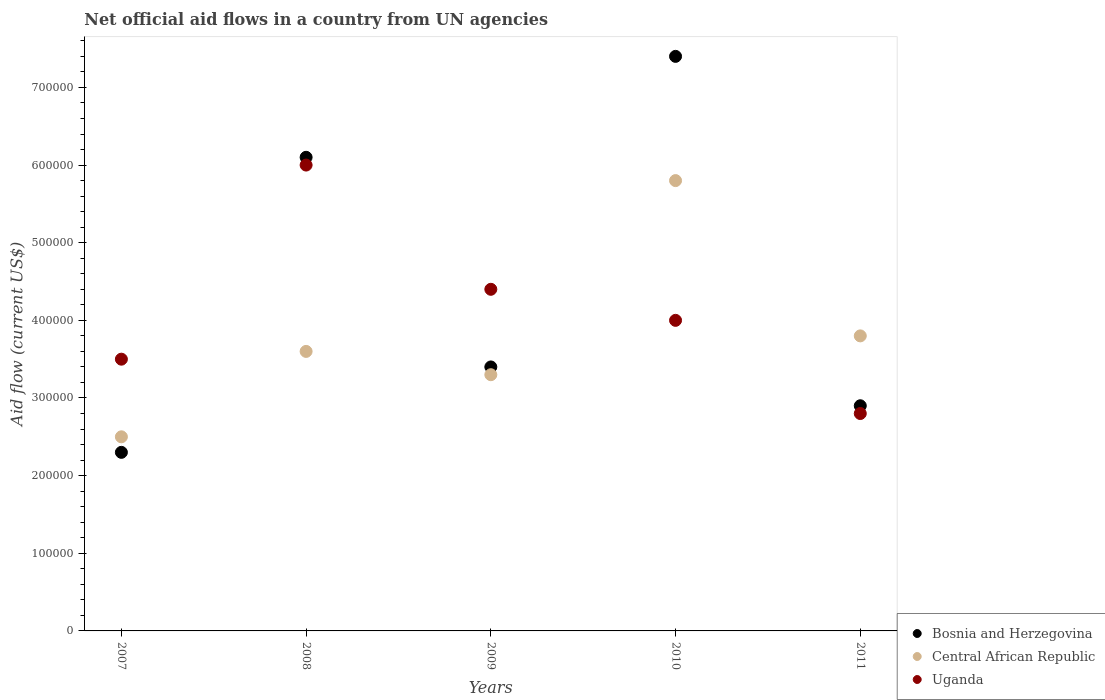How many different coloured dotlines are there?
Provide a succinct answer. 3. Is the number of dotlines equal to the number of legend labels?
Keep it short and to the point. Yes. What is the net official aid flow in Central African Republic in 2010?
Offer a very short reply. 5.80e+05. Across all years, what is the maximum net official aid flow in Bosnia and Herzegovina?
Give a very brief answer. 7.40e+05. Across all years, what is the minimum net official aid flow in Central African Republic?
Offer a very short reply. 2.50e+05. In which year was the net official aid flow in Bosnia and Herzegovina maximum?
Your answer should be compact. 2010. In which year was the net official aid flow in Uganda minimum?
Provide a short and direct response. 2011. What is the total net official aid flow in Central African Republic in the graph?
Make the answer very short. 1.90e+06. What is the difference between the net official aid flow in Bosnia and Herzegovina in 2009 and that in 2011?
Ensure brevity in your answer.  5.00e+04. What is the difference between the net official aid flow in Bosnia and Herzegovina in 2011 and the net official aid flow in Uganda in 2008?
Your response must be concise. -3.10e+05. In the year 2011, what is the difference between the net official aid flow in Uganda and net official aid flow in Bosnia and Herzegovina?
Ensure brevity in your answer.  -10000. What is the ratio of the net official aid flow in Uganda in 2007 to that in 2009?
Ensure brevity in your answer.  0.8. What is the difference between the highest and the lowest net official aid flow in Uganda?
Give a very brief answer. 3.20e+05. In how many years, is the net official aid flow in Central African Republic greater than the average net official aid flow in Central African Republic taken over all years?
Provide a succinct answer. 1. Is the sum of the net official aid flow in Uganda in 2007 and 2009 greater than the maximum net official aid flow in Bosnia and Herzegovina across all years?
Provide a short and direct response. Yes. What is the difference between two consecutive major ticks on the Y-axis?
Ensure brevity in your answer.  1.00e+05. Does the graph contain grids?
Offer a very short reply. No. Where does the legend appear in the graph?
Your response must be concise. Bottom right. How are the legend labels stacked?
Provide a succinct answer. Vertical. What is the title of the graph?
Offer a terse response. Net official aid flows in a country from UN agencies. Does "San Marino" appear as one of the legend labels in the graph?
Give a very brief answer. No. What is the label or title of the X-axis?
Offer a terse response. Years. What is the Aid flow (current US$) of Central African Republic in 2007?
Your answer should be compact. 2.50e+05. What is the Aid flow (current US$) in Uganda in 2007?
Offer a terse response. 3.50e+05. What is the Aid flow (current US$) of Uganda in 2008?
Keep it short and to the point. 6.00e+05. What is the Aid flow (current US$) of Bosnia and Herzegovina in 2009?
Offer a terse response. 3.40e+05. What is the Aid flow (current US$) of Bosnia and Herzegovina in 2010?
Offer a terse response. 7.40e+05. What is the Aid flow (current US$) in Central African Republic in 2010?
Provide a short and direct response. 5.80e+05. What is the Aid flow (current US$) in Uganda in 2010?
Your response must be concise. 4.00e+05. What is the Aid flow (current US$) of Bosnia and Herzegovina in 2011?
Provide a short and direct response. 2.90e+05. What is the Aid flow (current US$) of Central African Republic in 2011?
Your response must be concise. 3.80e+05. Across all years, what is the maximum Aid flow (current US$) of Bosnia and Herzegovina?
Provide a succinct answer. 7.40e+05. Across all years, what is the maximum Aid flow (current US$) of Central African Republic?
Offer a terse response. 5.80e+05. Across all years, what is the maximum Aid flow (current US$) of Uganda?
Your response must be concise. 6.00e+05. Across all years, what is the minimum Aid flow (current US$) of Central African Republic?
Give a very brief answer. 2.50e+05. Across all years, what is the minimum Aid flow (current US$) of Uganda?
Give a very brief answer. 2.80e+05. What is the total Aid flow (current US$) of Bosnia and Herzegovina in the graph?
Your answer should be compact. 2.21e+06. What is the total Aid flow (current US$) of Central African Republic in the graph?
Make the answer very short. 1.90e+06. What is the total Aid flow (current US$) in Uganda in the graph?
Your response must be concise. 2.07e+06. What is the difference between the Aid flow (current US$) of Bosnia and Herzegovina in 2007 and that in 2008?
Keep it short and to the point. -3.80e+05. What is the difference between the Aid flow (current US$) in Bosnia and Herzegovina in 2007 and that in 2009?
Offer a terse response. -1.10e+05. What is the difference between the Aid flow (current US$) in Central African Republic in 2007 and that in 2009?
Your answer should be very brief. -8.00e+04. What is the difference between the Aid flow (current US$) in Uganda in 2007 and that in 2009?
Make the answer very short. -9.00e+04. What is the difference between the Aid flow (current US$) in Bosnia and Herzegovina in 2007 and that in 2010?
Your answer should be very brief. -5.10e+05. What is the difference between the Aid flow (current US$) of Central African Republic in 2007 and that in 2010?
Make the answer very short. -3.30e+05. What is the difference between the Aid flow (current US$) in Central African Republic in 2007 and that in 2011?
Keep it short and to the point. -1.30e+05. What is the difference between the Aid flow (current US$) of Central African Republic in 2008 and that in 2009?
Keep it short and to the point. 3.00e+04. What is the difference between the Aid flow (current US$) of Uganda in 2008 and that in 2009?
Your response must be concise. 1.60e+05. What is the difference between the Aid flow (current US$) in Bosnia and Herzegovina in 2008 and that in 2010?
Keep it short and to the point. -1.30e+05. What is the difference between the Aid flow (current US$) of Bosnia and Herzegovina in 2009 and that in 2010?
Provide a short and direct response. -4.00e+05. What is the difference between the Aid flow (current US$) in Bosnia and Herzegovina in 2009 and that in 2011?
Offer a very short reply. 5.00e+04. What is the difference between the Aid flow (current US$) of Central African Republic in 2009 and that in 2011?
Keep it short and to the point. -5.00e+04. What is the difference between the Aid flow (current US$) of Uganda in 2009 and that in 2011?
Offer a terse response. 1.60e+05. What is the difference between the Aid flow (current US$) of Uganda in 2010 and that in 2011?
Your answer should be compact. 1.20e+05. What is the difference between the Aid flow (current US$) in Bosnia and Herzegovina in 2007 and the Aid flow (current US$) in Central African Republic in 2008?
Provide a short and direct response. -1.30e+05. What is the difference between the Aid flow (current US$) in Bosnia and Herzegovina in 2007 and the Aid flow (current US$) in Uganda in 2008?
Keep it short and to the point. -3.70e+05. What is the difference between the Aid flow (current US$) in Central African Republic in 2007 and the Aid flow (current US$) in Uganda in 2008?
Give a very brief answer. -3.50e+05. What is the difference between the Aid flow (current US$) in Bosnia and Herzegovina in 2007 and the Aid flow (current US$) in Central African Republic in 2009?
Your response must be concise. -1.00e+05. What is the difference between the Aid flow (current US$) of Central African Republic in 2007 and the Aid flow (current US$) of Uganda in 2009?
Give a very brief answer. -1.90e+05. What is the difference between the Aid flow (current US$) in Bosnia and Herzegovina in 2007 and the Aid flow (current US$) in Central African Republic in 2010?
Your answer should be compact. -3.50e+05. What is the difference between the Aid flow (current US$) in Central African Republic in 2007 and the Aid flow (current US$) in Uganda in 2010?
Provide a short and direct response. -1.50e+05. What is the difference between the Aid flow (current US$) in Bosnia and Herzegovina in 2008 and the Aid flow (current US$) in Uganda in 2009?
Keep it short and to the point. 1.70e+05. What is the difference between the Aid flow (current US$) in Bosnia and Herzegovina in 2008 and the Aid flow (current US$) in Uganda in 2011?
Offer a very short reply. 3.30e+05. What is the difference between the Aid flow (current US$) of Central African Republic in 2009 and the Aid flow (current US$) of Uganda in 2010?
Give a very brief answer. -7.00e+04. What is the difference between the Aid flow (current US$) in Bosnia and Herzegovina in 2009 and the Aid flow (current US$) in Uganda in 2011?
Make the answer very short. 6.00e+04. What is the difference between the Aid flow (current US$) of Bosnia and Herzegovina in 2010 and the Aid flow (current US$) of Central African Republic in 2011?
Make the answer very short. 3.60e+05. What is the difference between the Aid flow (current US$) of Bosnia and Herzegovina in 2010 and the Aid flow (current US$) of Uganda in 2011?
Make the answer very short. 4.60e+05. What is the average Aid flow (current US$) in Bosnia and Herzegovina per year?
Your answer should be compact. 4.42e+05. What is the average Aid flow (current US$) of Central African Republic per year?
Give a very brief answer. 3.80e+05. What is the average Aid flow (current US$) in Uganda per year?
Offer a very short reply. 4.14e+05. In the year 2007, what is the difference between the Aid flow (current US$) in Bosnia and Herzegovina and Aid flow (current US$) in Central African Republic?
Offer a very short reply. -2.00e+04. In the year 2007, what is the difference between the Aid flow (current US$) in Central African Republic and Aid flow (current US$) in Uganda?
Give a very brief answer. -1.00e+05. In the year 2008, what is the difference between the Aid flow (current US$) in Bosnia and Herzegovina and Aid flow (current US$) in Central African Republic?
Give a very brief answer. 2.50e+05. In the year 2009, what is the difference between the Aid flow (current US$) in Bosnia and Herzegovina and Aid flow (current US$) in Uganda?
Your answer should be very brief. -1.00e+05. In the year 2009, what is the difference between the Aid flow (current US$) of Central African Republic and Aid flow (current US$) of Uganda?
Offer a terse response. -1.10e+05. In the year 2010, what is the difference between the Aid flow (current US$) in Bosnia and Herzegovina and Aid flow (current US$) in Uganda?
Ensure brevity in your answer.  3.40e+05. What is the ratio of the Aid flow (current US$) of Bosnia and Herzegovina in 2007 to that in 2008?
Your answer should be compact. 0.38. What is the ratio of the Aid flow (current US$) in Central African Republic in 2007 to that in 2008?
Your answer should be compact. 0.69. What is the ratio of the Aid flow (current US$) in Uganda in 2007 to that in 2008?
Give a very brief answer. 0.58. What is the ratio of the Aid flow (current US$) of Bosnia and Herzegovina in 2007 to that in 2009?
Provide a succinct answer. 0.68. What is the ratio of the Aid flow (current US$) of Central African Republic in 2007 to that in 2009?
Offer a terse response. 0.76. What is the ratio of the Aid flow (current US$) of Uganda in 2007 to that in 2009?
Offer a terse response. 0.8. What is the ratio of the Aid flow (current US$) of Bosnia and Herzegovina in 2007 to that in 2010?
Your answer should be very brief. 0.31. What is the ratio of the Aid flow (current US$) of Central African Republic in 2007 to that in 2010?
Your answer should be very brief. 0.43. What is the ratio of the Aid flow (current US$) in Uganda in 2007 to that in 2010?
Offer a terse response. 0.88. What is the ratio of the Aid flow (current US$) in Bosnia and Herzegovina in 2007 to that in 2011?
Your response must be concise. 0.79. What is the ratio of the Aid flow (current US$) in Central African Republic in 2007 to that in 2011?
Offer a very short reply. 0.66. What is the ratio of the Aid flow (current US$) in Uganda in 2007 to that in 2011?
Provide a succinct answer. 1.25. What is the ratio of the Aid flow (current US$) in Bosnia and Herzegovina in 2008 to that in 2009?
Your answer should be compact. 1.79. What is the ratio of the Aid flow (current US$) of Central African Republic in 2008 to that in 2009?
Offer a very short reply. 1.09. What is the ratio of the Aid flow (current US$) of Uganda in 2008 to that in 2009?
Provide a short and direct response. 1.36. What is the ratio of the Aid flow (current US$) in Bosnia and Herzegovina in 2008 to that in 2010?
Offer a terse response. 0.82. What is the ratio of the Aid flow (current US$) of Central African Republic in 2008 to that in 2010?
Your response must be concise. 0.62. What is the ratio of the Aid flow (current US$) in Bosnia and Herzegovina in 2008 to that in 2011?
Offer a very short reply. 2.1. What is the ratio of the Aid flow (current US$) in Uganda in 2008 to that in 2011?
Offer a terse response. 2.14. What is the ratio of the Aid flow (current US$) of Bosnia and Herzegovina in 2009 to that in 2010?
Your answer should be very brief. 0.46. What is the ratio of the Aid flow (current US$) in Central African Republic in 2009 to that in 2010?
Offer a terse response. 0.57. What is the ratio of the Aid flow (current US$) in Bosnia and Herzegovina in 2009 to that in 2011?
Make the answer very short. 1.17. What is the ratio of the Aid flow (current US$) in Central African Republic in 2009 to that in 2011?
Offer a terse response. 0.87. What is the ratio of the Aid flow (current US$) of Uganda in 2009 to that in 2011?
Your response must be concise. 1.57. What is the ratio of the Aid flow (current US$) in Bosnia and Herzegovina in 2010 to that in 2011?
Offer a terse response. 2.55. What is the ratio of the Aid flow (current US$) in Central African Republic in 2010 to that in 2011?
Your response must be concise. 1.53. What is the ratio of the Aid flow (current US$) of Uganda in 2010 to that in 2011?
Offer a terse response. 1.43. What is the difference between the highest and the second highest Aid flow (current US$) in Central African Republic?
Your answer should be very brief. 2.00e+05. What is the difference between the highest and the lowest Aid flow (current US$) of Bosnia and Herzegovina?
Your answer should be compact. 5.10e+05. What is the difference between the highest and the lowest Aid flow (current US$) of Central African Republic?
Give a very brief answer. 3.30e+05. What is the difference between the highest and the lowest Aid flow (current US$) of Uganda?
Offer a very short reply. 3.20e+05. 